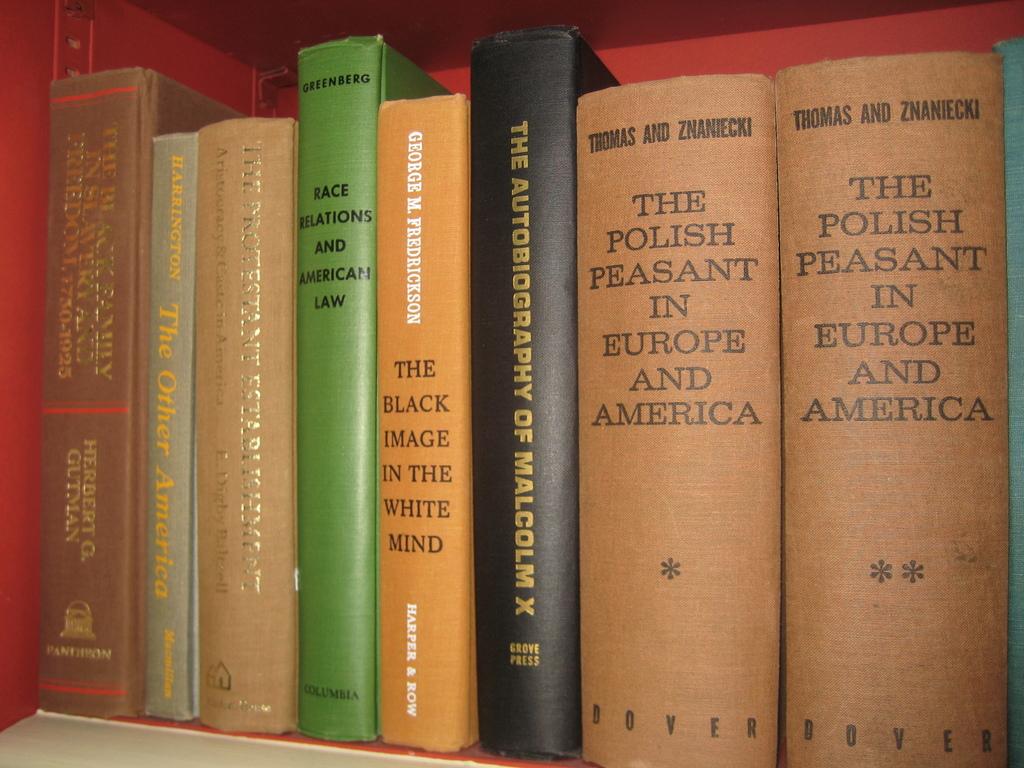What is the title of the two volume book?
Your response must be concise. The polish peasant in europe and america. 